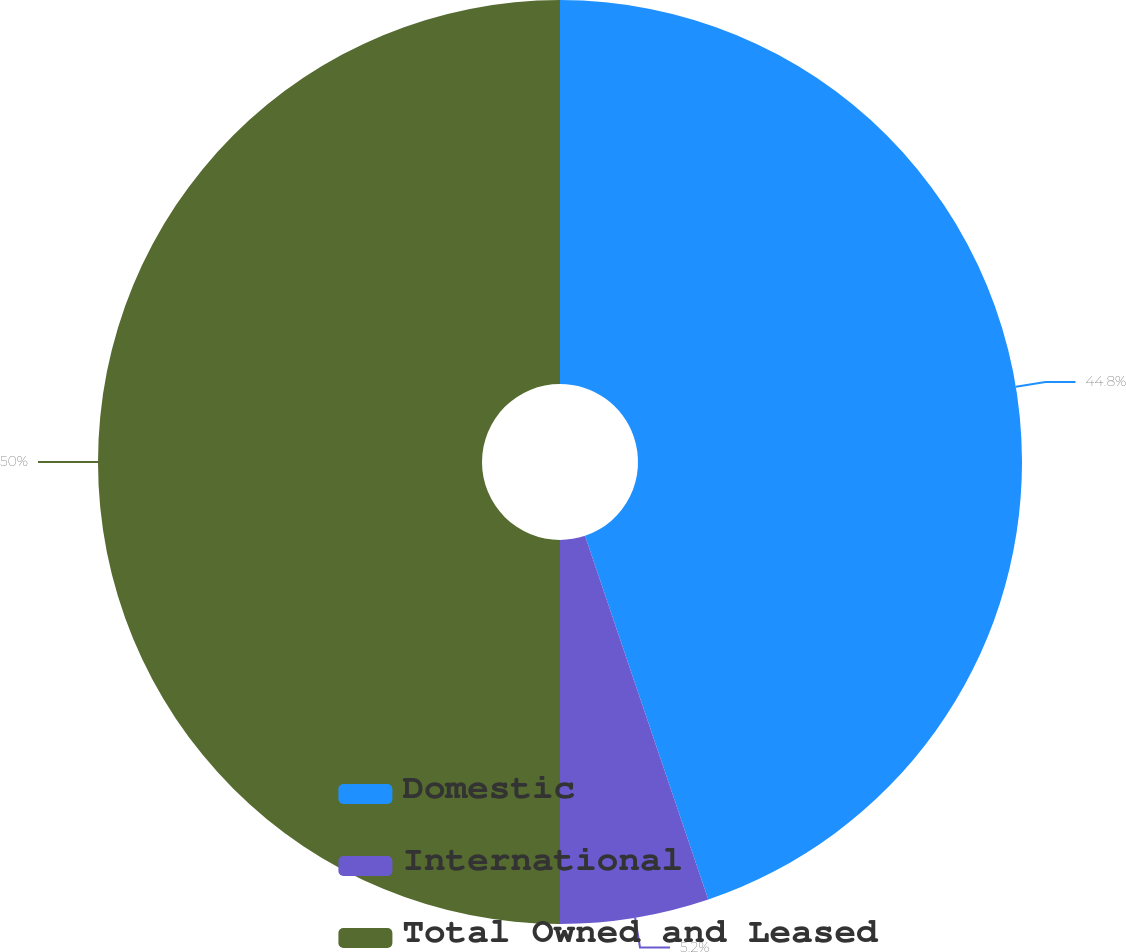Convert chart to OTSL. <chart><loc_0><loc_0><loc_500><loc_500><pie_chart><fcel>Domestic<fcel>International<fcel>Total Owned and Leased<nl><fcel>44.8%<fcel>5.2%<fcel>50.0%<nl></chart> 